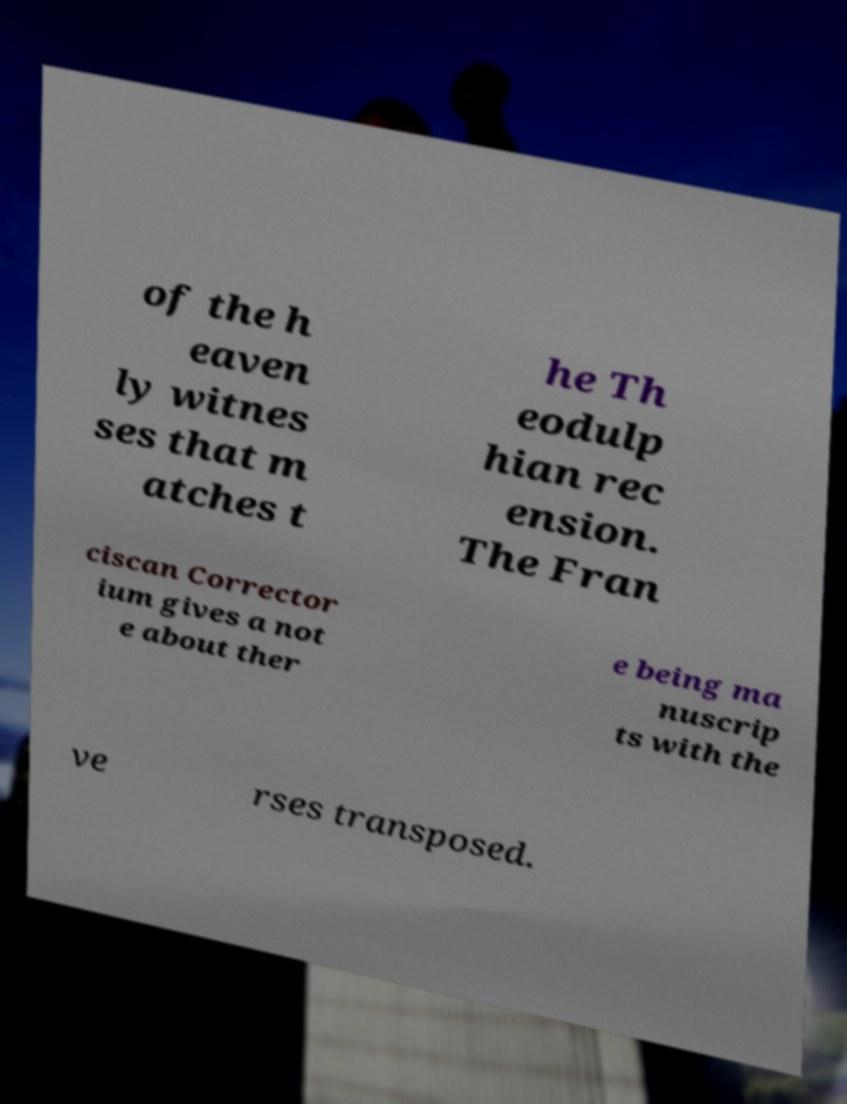Please read and relay the text visible in this image. What does it say? of the h eaven ly witnes ses that m atches t he Th eodulp hian rec ension. The Fran ciscan Corrector ium gives a not e about ther e being ma nuscrip ts with the ve rses transposed. 